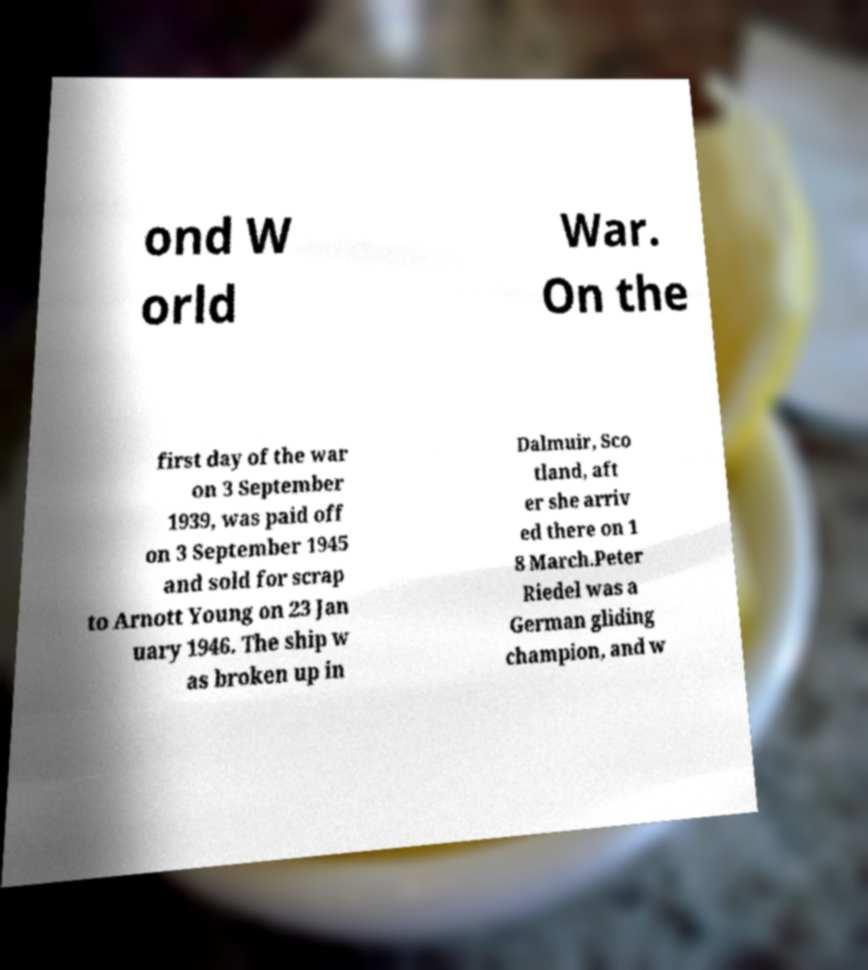There's text embedded in this image that I need extracted. Can you transcribe it verbatim? ond W orld War. On the first day of the war on 3 September 1939, was paid off on 3 September 1945 and sold for scrap to Arnott Young on 23 Jan uary 1946. The ship w as broken up in Dalmuir, Sco tland, aft er she arriv ed there on 1 8 March.Peter Riedel was a German gliding champion, and w 